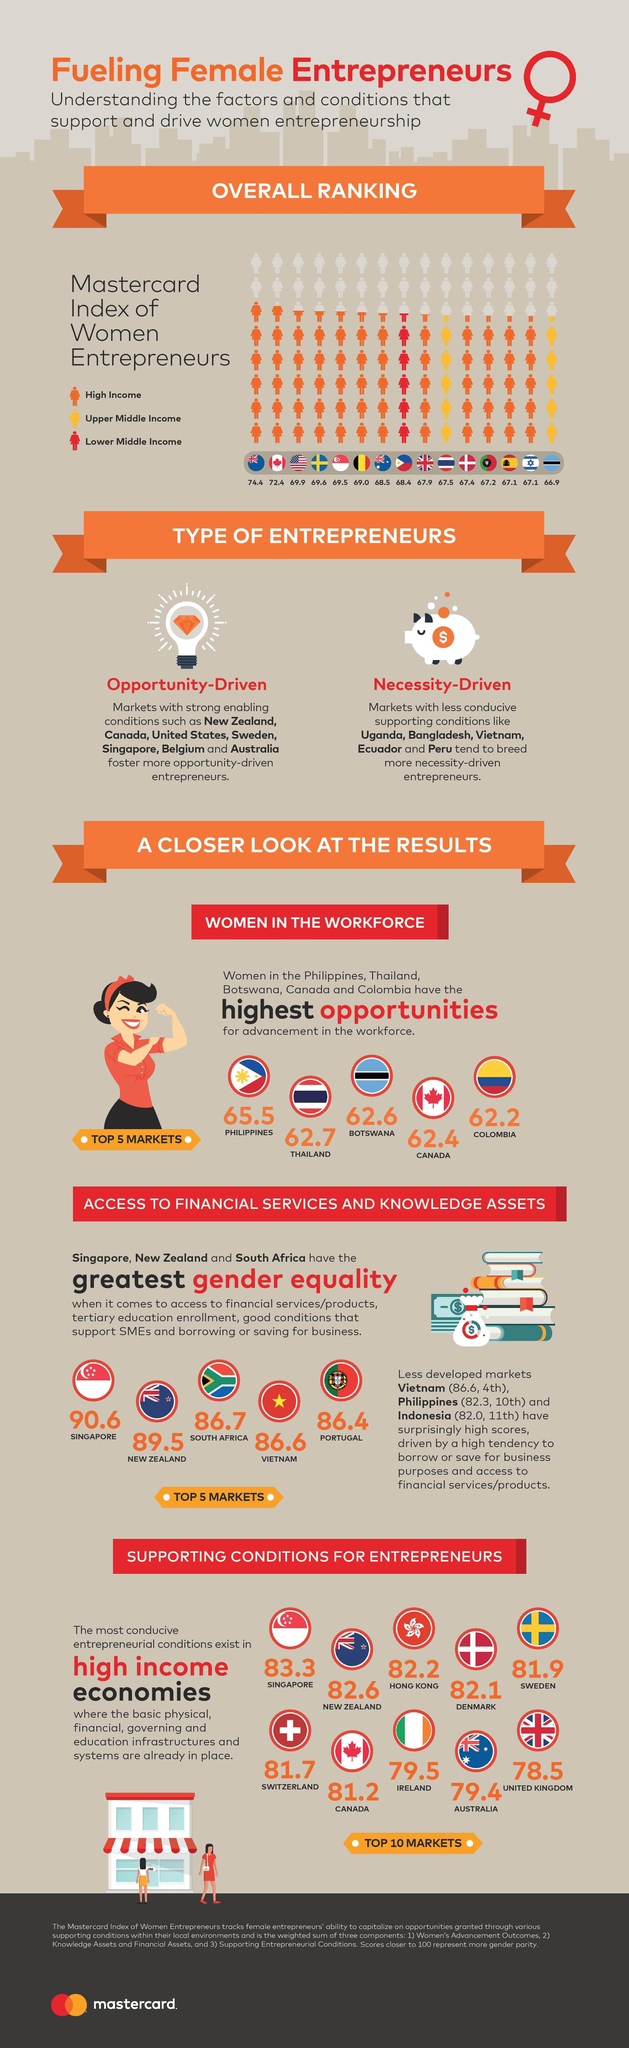List a handful of essential elements in this visual. Ireland ranks eighth among high-income economies. The score of Portugal in gender equality is 86.4. According to the provided information, Canada comes fourth in providing higher opportunities for women. According to a recent survey, Hong Kong's score in income generation is 82.2. According to a recent survey, two countries have businesswomen who earn upper-middle income: Thailand and Botswana. 